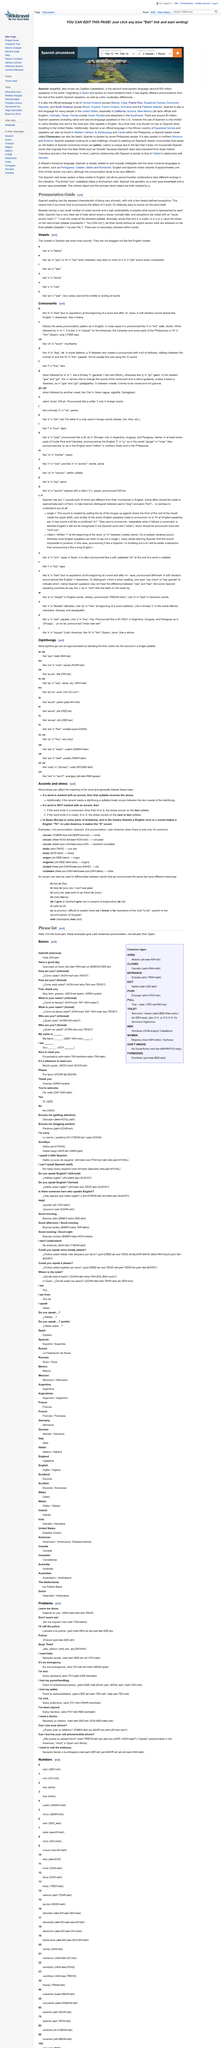Specify some key components in this picture. Spanish has a small number of vowel sounds while also being very phonetic. It is certainly not the case that there are any secondary stresses within words in Spanish. Yes, Spanish does use accent marks. 